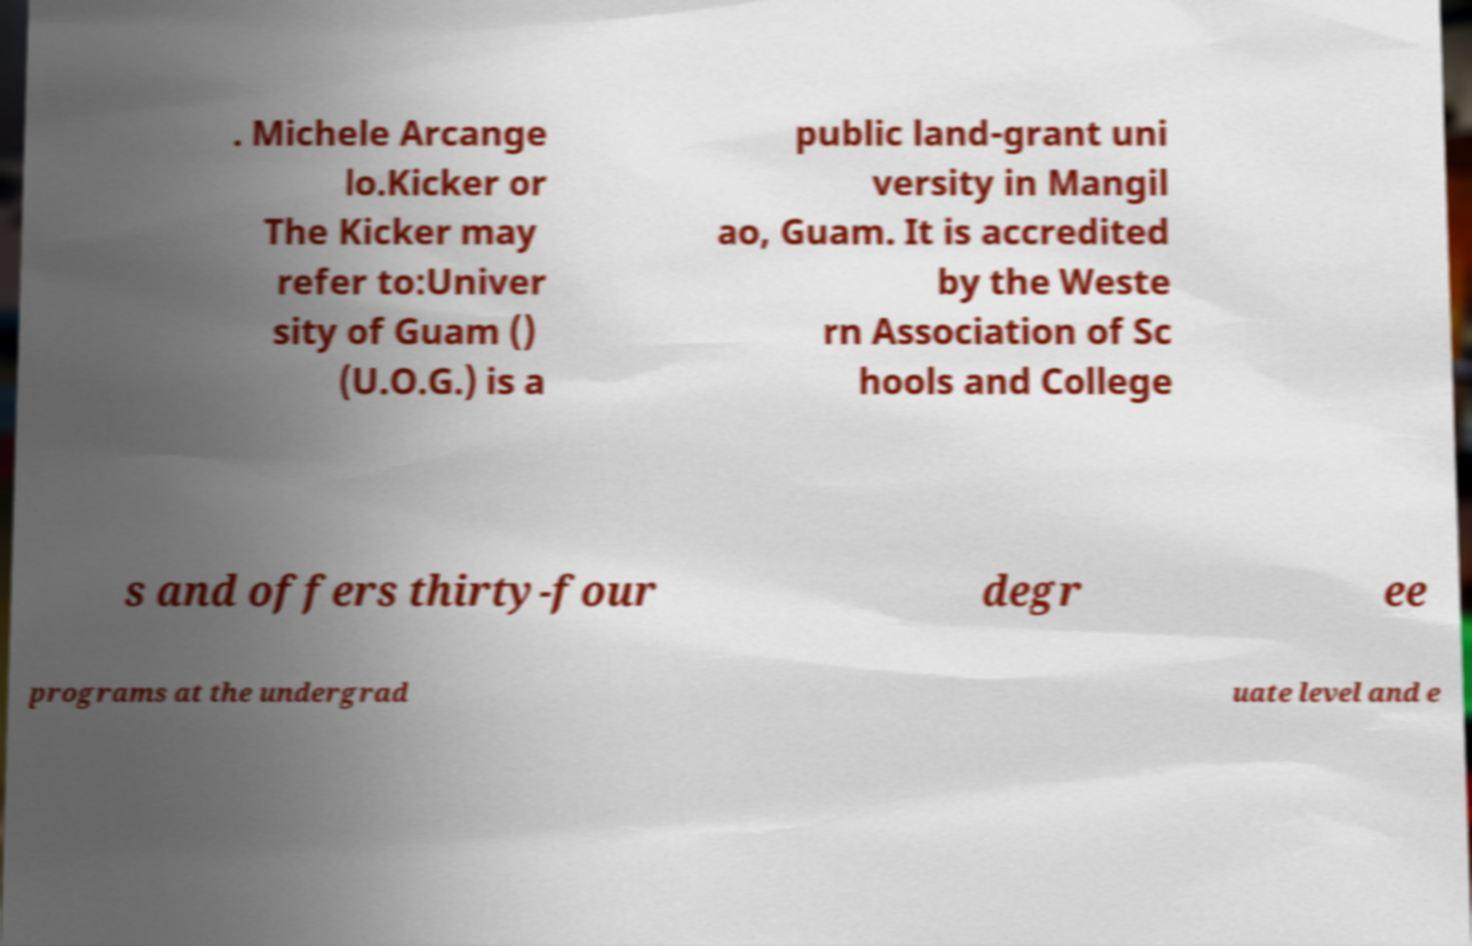What messages or text are displayed in this image? I need them in a readable, typed format. . Michele Arcange lo.Kicker or The Kicker may refer to:Univer sity of Guam () (U.O.G.) is a public land-grant uni versity in Mangil ao, Guam. It is accredited by the Weste rn Association of Sc hools and College s and offers thirty-four degr ee programs at the undergrad uate level and e 